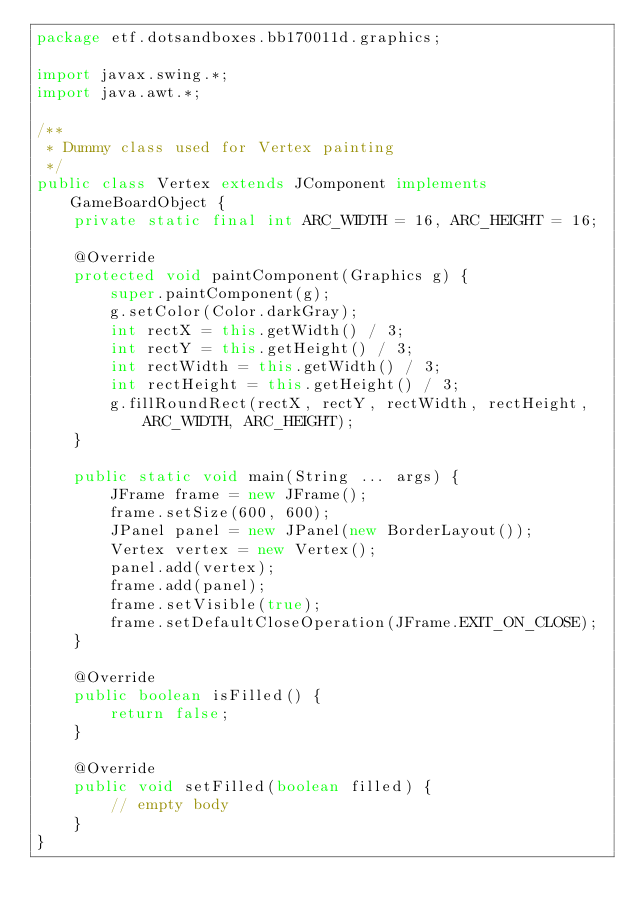Convert code to text. <code><loc_0><loc_0><loc_500><loc_500><_Java_>package etf.dotsandboxes.bb170011d.graphics;

import javax.swing.*;
import java.awt.*;

/**
 * Dummy class used for Vertex painting
 */
public class Vertex extends JComponent implements GameBoardObject {
    private static final int ARC_WIDTH = 16, ARC_HEIGHT = 16;

    @Override
    protected void paintComponent(Graphics g) {
        super.paintComponent(g);
        g.setColor(Color.darkGray);
        int rectX = this.getWidth() / 3;
        int rectY = this.getHeight() / 3;
        int rectWidth = this.getWidth() / 3;
        int rectHeight = this.getHeight() / 3;
        g.fillRoundRect(rectX, rectY, rectWidth, rectHeight, ARC_WIDTH, ARC_HEIGHT);
    }

    public static void main(String ... args) {
        JFrame frame = new JFrame();
        frame.setSize(600, 600);
        JPanel panel = new JPanel(new BorderLayout());
        Vertex vertex = new Vertex();
        panel.add(vertex);
        frame.add(panel);
        frame.setVisible(true);
        frame.setDefaultCloseOperation(JFrame.EXIT_ON_CLOSE);
    }

    @Override
    public boolean isFilled() {
        return false;
    }

    @Override
    public void setFilled(boolean filled) {
        // empty body
    }
}
</code> 